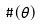<formula> <loc_0><loc_0><loc_500><loc_500>\# ( \theta )</formula> 